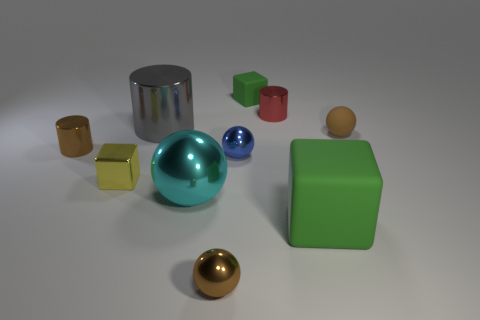Subtract all spheres. How many objects are left? 6 Subtract all large metallic spheres. Subtract all blue balls. How many objects are left? 8 Add 6 small brown metal cylinders. How many small brown metal cylinders are left? 7 Add 5 large gray metallic cylinders. How many large gray metallic cylinders exist? 6 Subtract 0 purple balls. How many objects are left? 10 